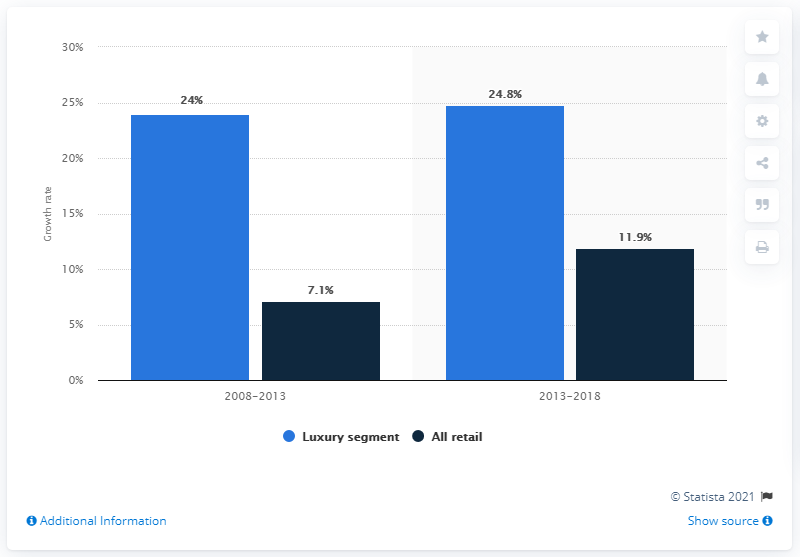Give some essential details in this illustration. During the period of 2008 to 2013, the percentage of luxury segments was approximately 24%. The luxury segment between the two years shows a difference of 0.8. 